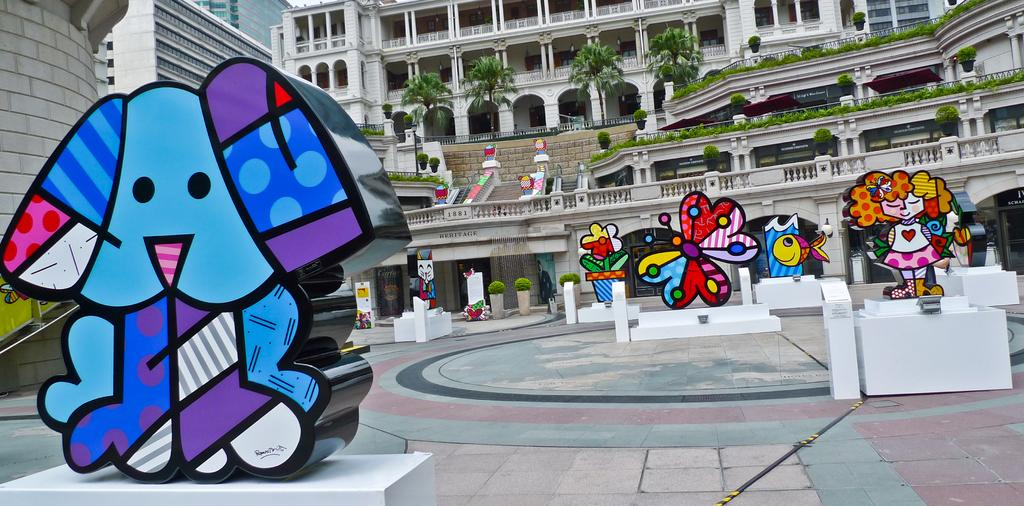What type of surface is visible in the image? There is a floor visible in the image. What are the statues standing on in the image? The statues are on pedestals in the image. What type of vegetation can be seen in the image? There are plants and trees in the image. What type of structures are present in the image? There are buildings in the image. What else can be seen in the image besides the statues, plants, trees, and buildings? There are some objects in the image. What is the name of the game being played by the statues in the image? There are no games being played by the statues in the image; they are standing on pedestals. What type of cushion is used to support the plants in the image? There are no cushions present in the image; the plants are not supported by any cushions. 